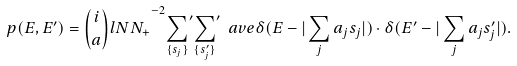<formula> <loc_0><loc_0><loc_500><loc_500>p ( E , E ^ { \prime } ) = { \binom { i } { a } l { N } { N _ { + } } } ^ { - 2 } { \sum _ { \{ s _ { j } \} } } ^ { \prime } { \sum _ { \{ s ^ { \prime } _ { j } \} } } ^ { \prime } \ a v e { \delta ( E - | \sum _ { j } a _ { j } s _ { j } | ) \cdot \delta ( E ^ { \prime } - | \sum _ { j } a _ { j } s ^ { \prime } _ { j } | ) } .</formula> 